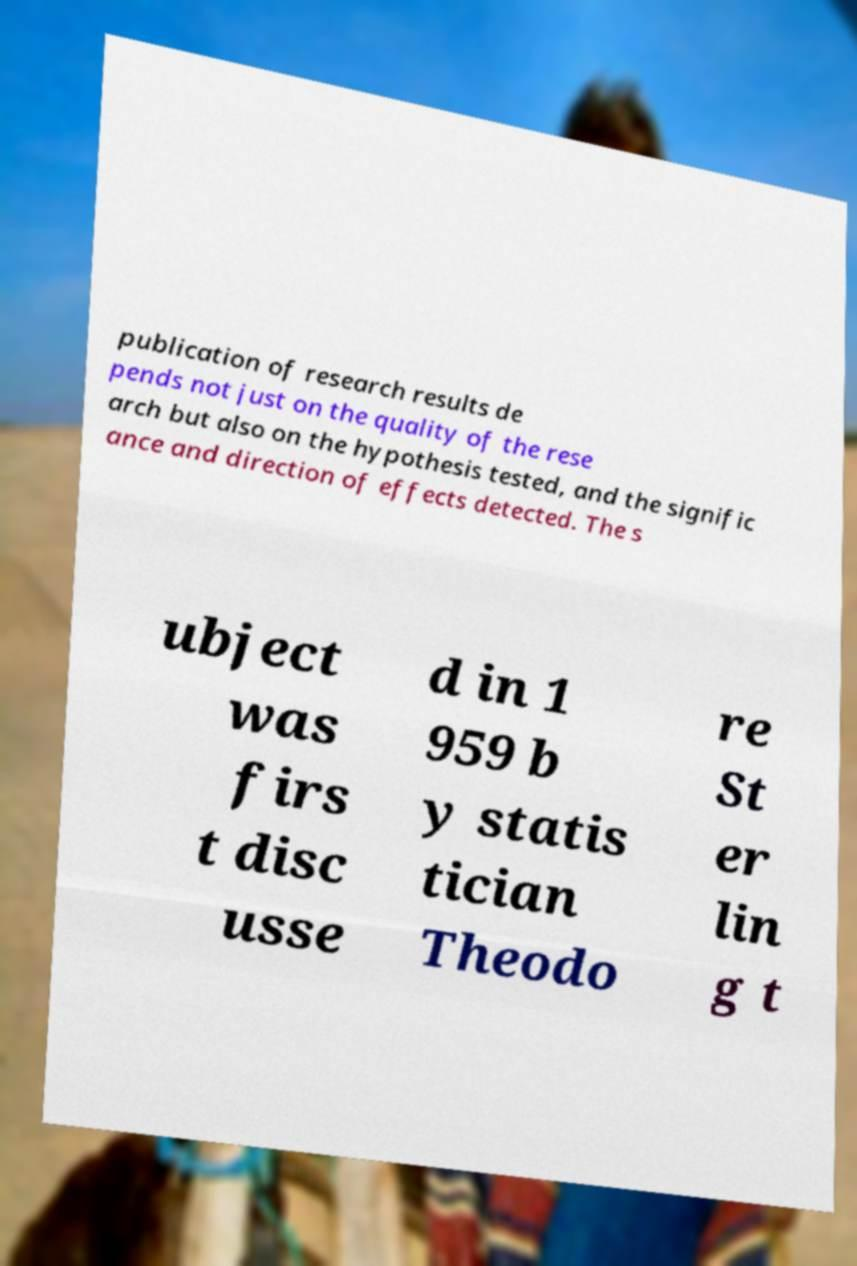Could you assist in decoding the text presented in this image and type it out clearly? publication of research results de pends not just on the quality of the rese arch but also on the hypothesis tested, and the signific ance and direction of effects detected. The s ubject was firs t disc usse d in 1 959 b y statis tician Theodo re St er lin g t 